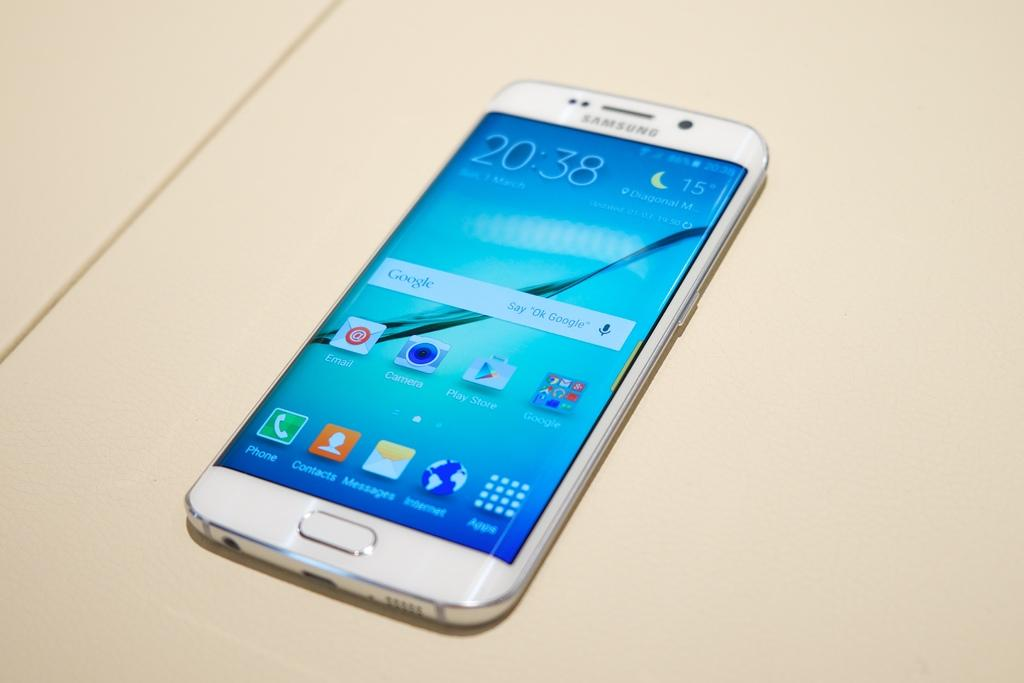Provide a one-sentence caption for the provided image. A white Iphone with apps on the front and the time 20:30. 